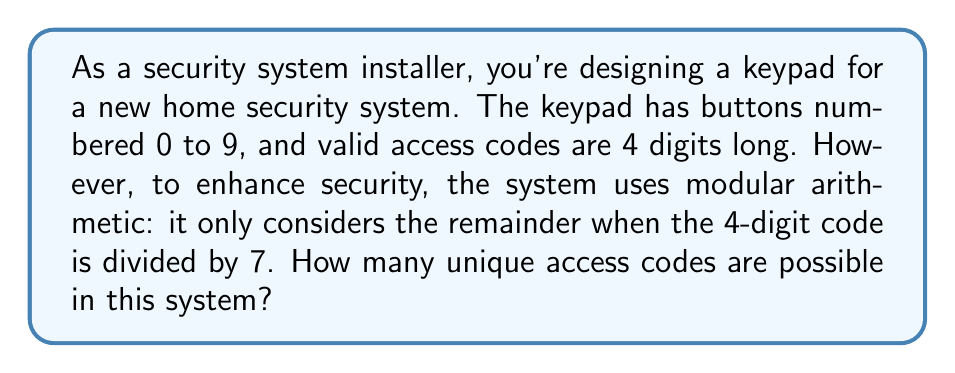Help me with this question. Let's approach this step-by-step:

1) First, we need to understand what the question is asking. The system is using modular arithmetic with modulus 7. This means that two 4-digit codes are considered the same if they have the same remainder when divided by 7.

2) In modular arithmetic, we say two numbers $a$ and $b$ are congruent modulo $n$ if $a \equiv b \pmod{n}$. In this case, $n = 7$.

3) Now, let's consider a 4-digit number $abcd$ (where $a$, $b$, $c$, and $d$ are single digits). In base 10, this number is equal to:

   $abcd = 1000a + 100b + 10c + d$

4) In modular arithmetic with modulus 7, we can simplify this:

   $1000 \equiv 6 \pmod{7}$
   $100 \equiv 2 \pmod{7}$
   $10 \equiv 3 \pmod{7}$
   $1 \equiv 1 \pmod{7}$

5) Therefore, in our system, the number $abcd$ is equivalent to:

   $6a + 2b + 3c + d \pmod{7}$

6) This means that for any 4-digit number, its "value" in this system is determined by the remainder when $(6a + 2b + 3c + d)$ is divided by 7.

7) The possible results of this calculation are the integers from 0 to 6 (7 possibilities).

8) Therefore, the number of unique access codes in this system is 7.
Answer: 7 unique access codes 